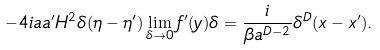Convert formula to latex. <formula><loc_0><loc_0><loc_500><loc_500>- 4 i a a ^ { \prime } H ^ { 2 } \delta ( \eta - \eta ^ { \prime } ) \lim _ { \delta \rightarrow 0 } f ^ { \prime } ( y ) \delta = \frac { i } { \beta a ^ { D - 2 } } \delta ^ { D } ( x - x ^ { \prime } ) .</formula> 